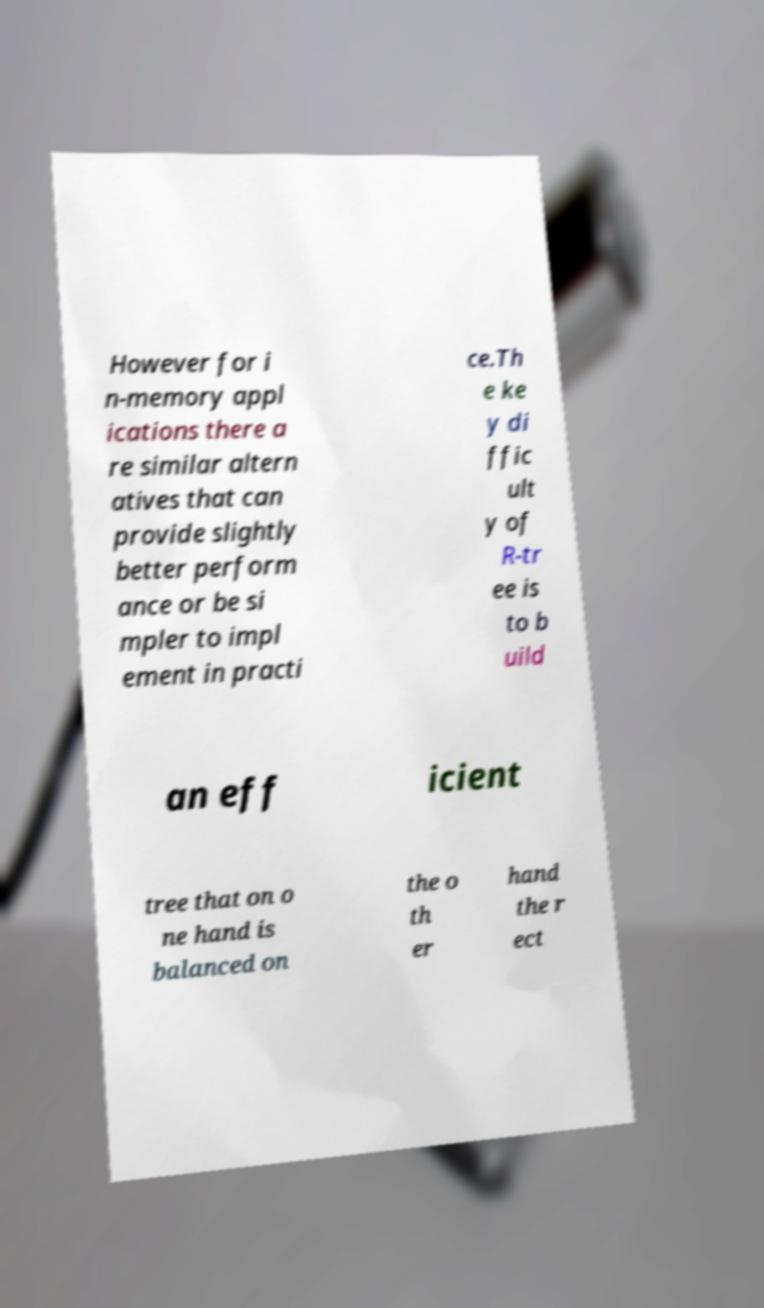What messages or text are displayed in this image? I need them in a readable, typed format. However for i n-memory appl ications there a re similar altern atives that can provide slightly better perform ance or be si mpler to impl ement in practi ce.Th e ke y di ffic ult y of R-tr ee is to b uild an eff icient tree that on o ne hand is balanced on the o th er hand the r ect 